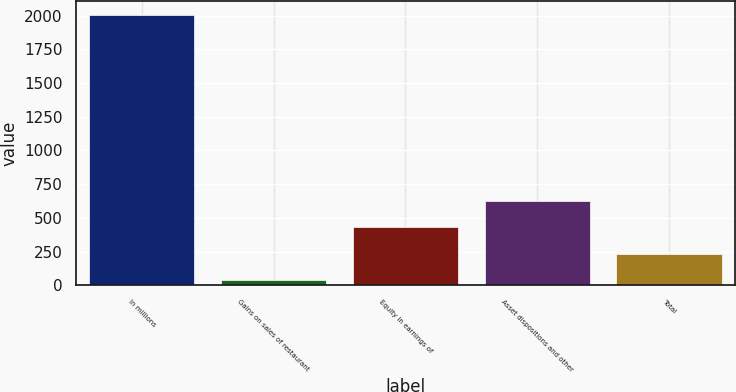<chart> <loc_0><loc_0><loc_500><loc_500><bar_chart><fcel>In millions<fcel>Gains on sales of restaurant<fcel>Equity in earnings of<fcel>Asset dispositions and other<fcel>Total<nl><fcel>2006<fcel>38<fcel>431.6<fcel>628.4<fcel>234.8<nl></chart> 